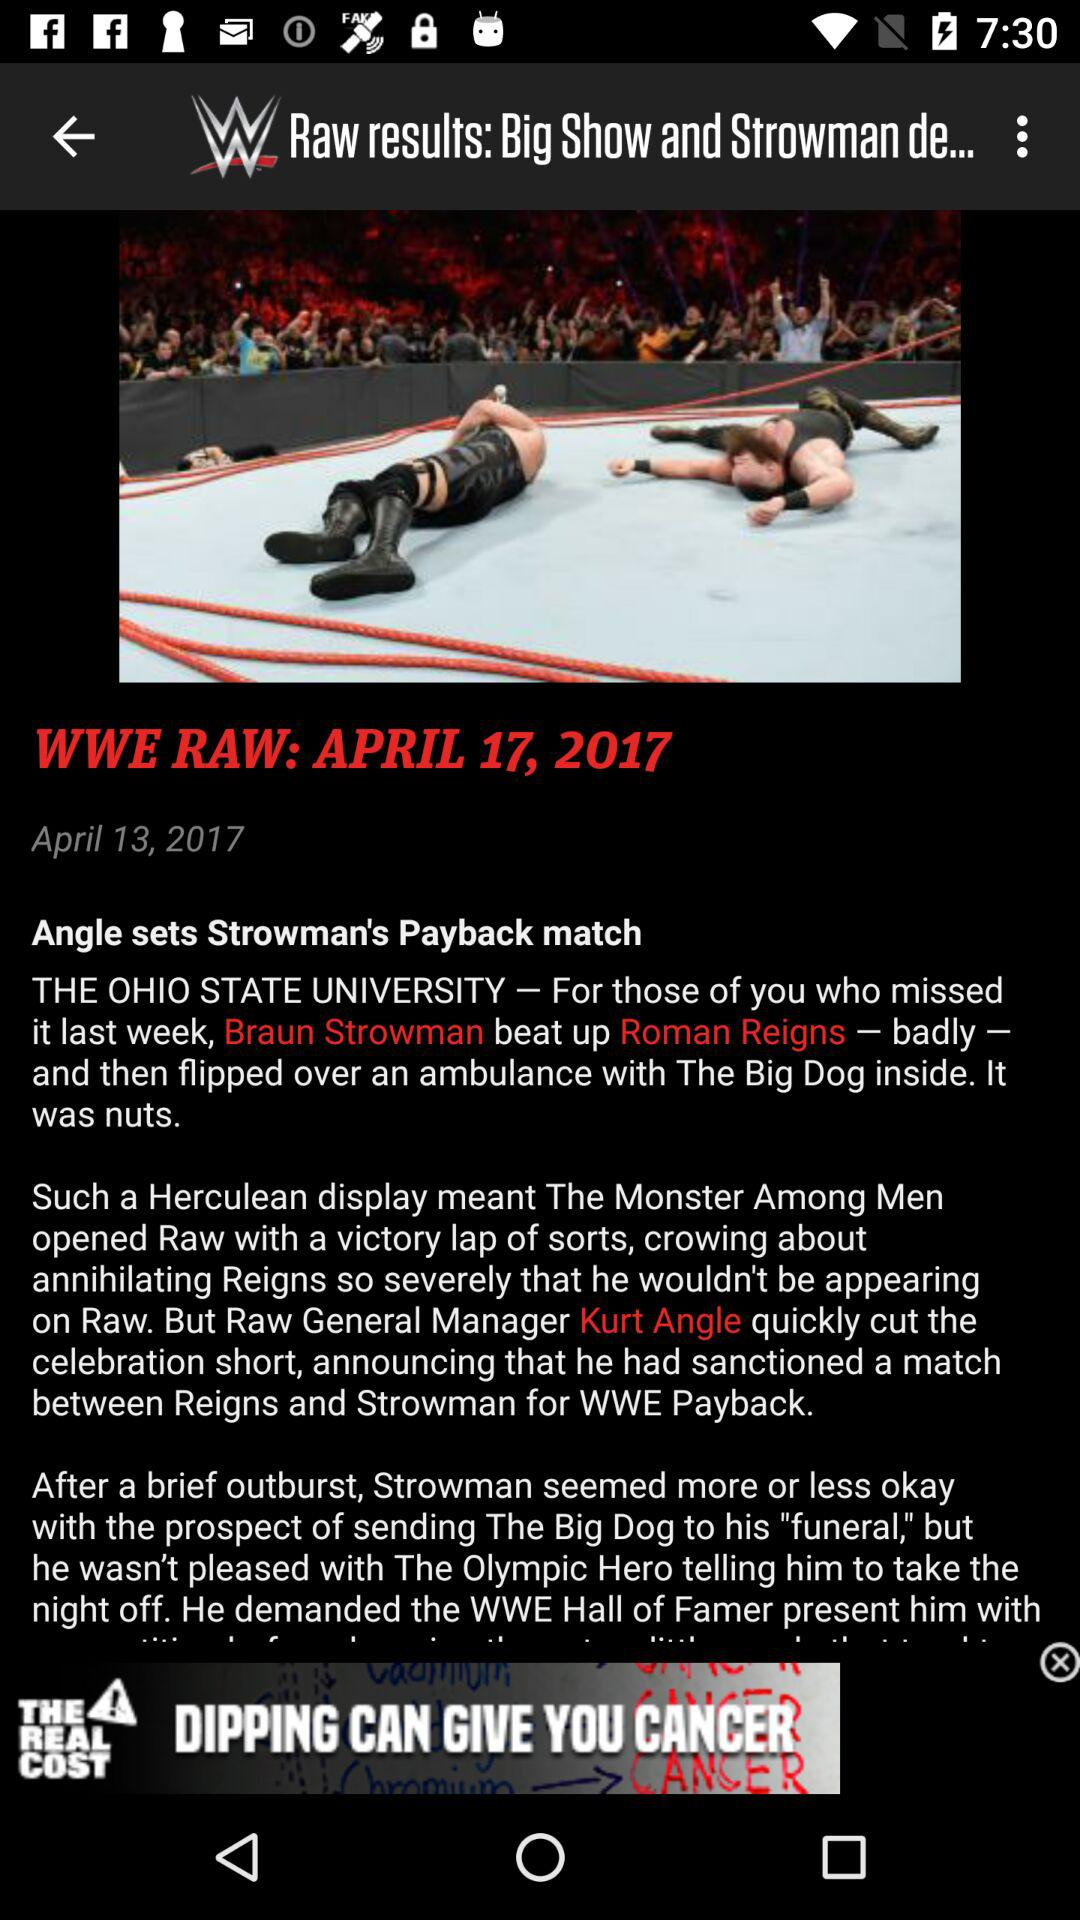Whom did Braun Strowman beat up? Braun Strowman beat up Roman Reigns. 